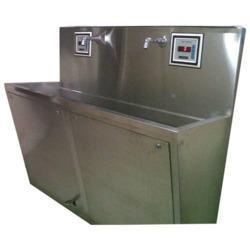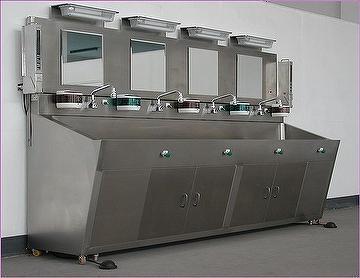The first image is the image on the left, the second image is the image on the right. Examine the images to the left and right. Is the description "There is exactly one faucet in the left image." accurate? Answer yes or no. No. 